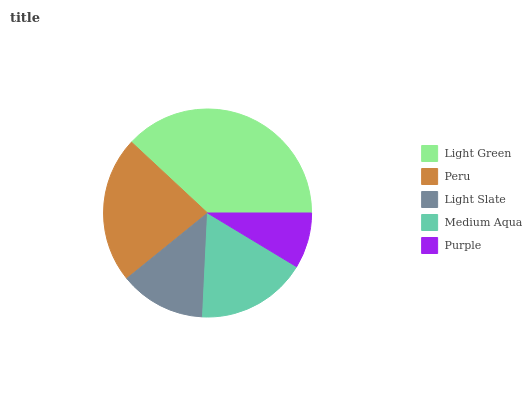Is Purple the minimum?
Answer yes or no. Yes. Is Light Green the maximum?
Answer yes or no. Yes. Is Peru the minimum?
Answer yes or no. No. Is Peru the maximum?
Answer yes or no. No. Is Light Green greater than Peru?
Answer yes or no. Yes. Is Peru less than Light Green?
Answer yes or no. Yes. Is Peru greater than Light Green?
Answer yes or no. No. Is Light Green less than Peru?
Answer yes or no. No. Is Medium Aqua the high median?
Answer yes or no. Yes. Is Medium Aqua the low median?
Answer yes or no. Yes. Is Light Green the high median?
Answer yes or no. No. Is Light Slate the low median?
Answer yes or no. No. 